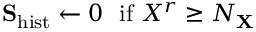<formula> <loc_0><loc_0><loc_500><loc_500>S _ { h i s t } \leftarrow 0 \ \ i f \ X ^ { r } \geq N _ { X }</formula> 